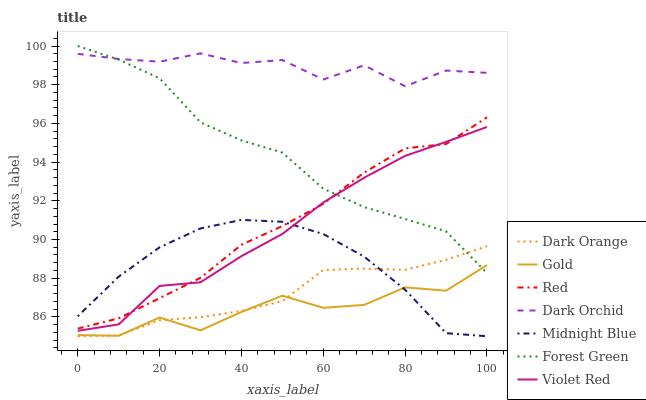Does Gold have the minimum area under the curve?
Answer yes or no. Yes. Does Dark Orchid have the maximum area under the curve?
Answer yes or no. Yes. Does Violet Red have the minimum area under the curve?
Answer yes or no. No. Does Violet Red have the maximum area under the curve?
Answer yes or no. No. Is Red the smoothest?
Answer yes or no. Yes. Is Gold the roughest?
Answer yes or no. Yes. Is Violet Red the smoothest?
Answer yes or no. No. Is Violet Red the roughest?
Answer yes or no. No. Does Dark Orange have the lowest value?
Answer yes or no. Yes. Does Violet Red have the lowest value?
Answer yes or no. No. Does Forest Green have the highest value?
Answer yes or no. Yes. Does Violet Red have the highest value?
Answer yes or no. No. Is Gold less than Red?
Answer yes or no. Yes. Is Dark Orchid greater than Gold?
Answer yes or no. Yes. Does Midnight Blue intersect Violet Red?
Answer yes or no. Yes. Is Midnight Blue less than Violet Red?
Answer yes or no. No. Is Midnight Blue greater than Violet Red?
Answer yes or no. No. Does Gold intersect Red?
Answer yes or no. No. 